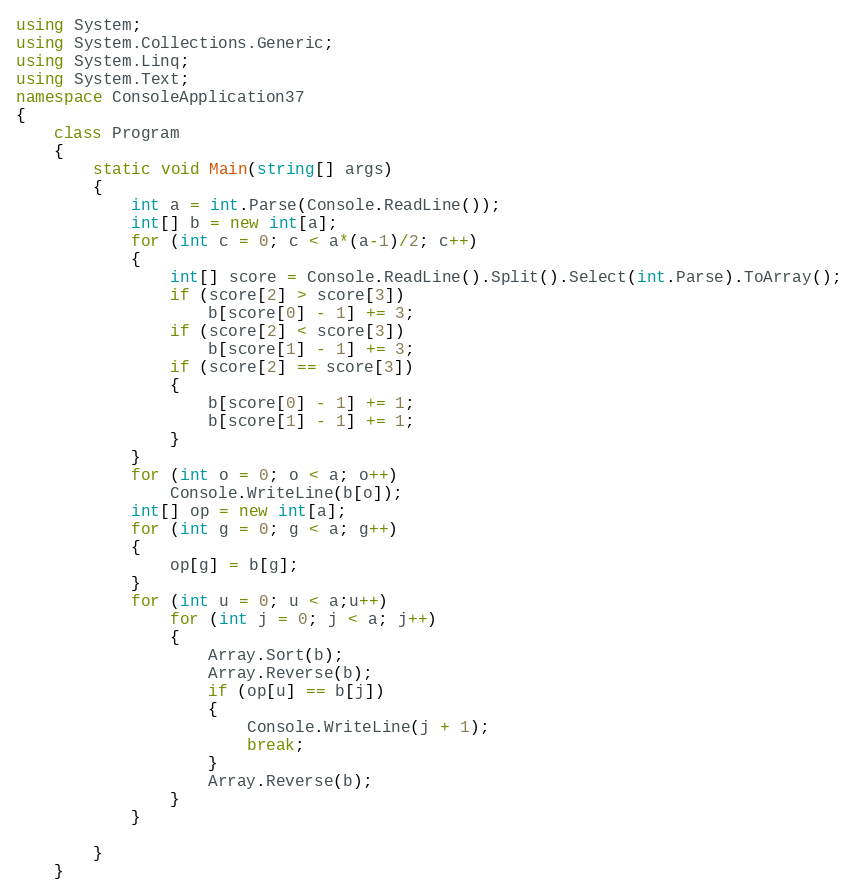<code> <loc_0><loc_0><loc_500><loc_500><_C#_>using System;
using System.Collections.Generic;
using System.Linq;
using System.Text;
namespace ConsoleApplication37
{
    class Program
    {
        static void Main(string[] args)
        {
            int a = int.Parse(Console.ReadLine());
            int[] b = new int[a];
            for (int c = 0; c < a*(a-1)/2; c++)
            {
                int[] score = Console.ReadLine().Split().Select(int.Parse).ToArray();
                if (score[2] > score[3])
                    b[score[0] - 1] += 3;
                if (score[2] < score[3])
                    b[score[1] - 1] += 3;
                if (score[2] == score[3])
                {
                    b[score[0] - 1] += 1;
                    b[score[1] - 1] += 1;
                }
            }
            for (int o = 0; o < a; o++)
                Console.WriteLine(b[o]);
            int[] op = new int[a];
            for (int g = 0; g < a; g++)
            {
                op[g] = b[g];
            }
            for (int u = 0; u < a;u++)
                for (int j = 0; j < a; j++)
                {
                    Array.Sort(b);
                    Array.Reverse(b);
                    if (op[u] == b[j])
                    {
                        Console.WriteLine(j + 1);
                        break;
                    }
                    Array.Reverse(b);
                }
            }
           
        }
    }</code> 